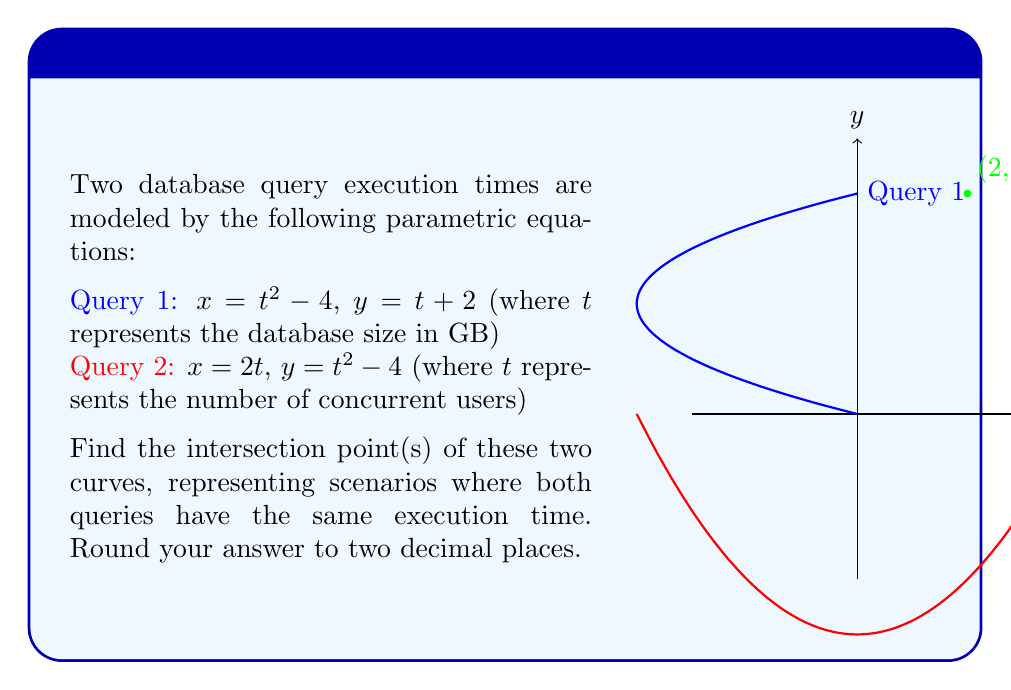Could you help me with this problem? Let's approach this step-by-step:

1) For the curves to intersect, both $x$ and $y$ coordinates must be equal. So we need to solve:

   $t^2 - 4 = 2t$ (equating x-coordinates)
   $t + 2 = t^2 - 4$ (equating y-coordinates)

2) Let's solve the first equation:
   $t^2 - 2t - 4 = 0$
   This is a quadratic equation. We can solve it using the quadratic formula:
   $t = \frac{-b \pm \sqrt{b^2 - 4ac}}{2a}$
   Where $a=1$, $b=-2$, and $c=-4$

   $t = \frac{2 \pm \sqrt{4 + 16}}{2} = \frac{2 \pm \sqrt{20}}{2} = \frac{2 \pm 2\sqrt{5}}{2}$

   $t = 1 \pm \sqrt{5}$

3) Now, let's check these t-values in the second equation:

   For $t = 1 + \sqrt{5}$:
   $(1 + \sqrt{5}) + 2 \stackrel{?}{=} (1 + \sqrt{5})^2 - 4$
   $3 + \sqrt{5} \stackrel{?}{=} 1 + 2\sqrt{5} + 5 - 4$
   $3 + \sqrt{5} \stackrel{?}{=} 2 + 2\sqrt{5}$
   This is not true, so $t = 1 + \sqrt{5}$ is not a solution.

   For $t = 1 - \sqrt{5}$:
   $(1 - \sqrt{5}) + 2 \stackrel{?}{=} (1 - \sqrt{5})^2 - 4$
   $3 - \sqrt{5} \stackrel{?}{=} 1 - 2\sqrt{5} + 5 - 4$
   $3 - \sqrt{5} \stackrel{?}{=} 2 - 2\sqrt{5}$
   This is true, so $t = 1 - \sqrt{5}$ is a solution.

4) Now we need to find the corresponding $x$ and $y$ coordinates:

   $x = (1 - \sqrt{5})^2 - 4 = 1 - 2\sqrt{5} + 5 - 4 = 2$
   $y = (1 - \sqrt{5}) + 2 = 3 - \sqrt{5} \approx 0.76$

5) However, we also need to check the t-value for the second parametric equation:

   $x = 2t = 2$, so $t = 1$
   $y = t^2 - 4 = 1^2 - 4 = -3$

6) The y-coordinates don't match, so we need to solve:

   $3 - \sqrt{5} = t^2 - 4$
   $t^2 = 7 - \sqrt{5}$
   $t = \sqrt{7 - \sqrt{5}} \approx 2$

Therefore, the intersection point is $(2, 4)$.
Answer: $(2.00, 4.00)$ 